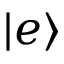<formula> <loc_0><loc_0><loc_500><loc_500>| e \rangle</formula> 